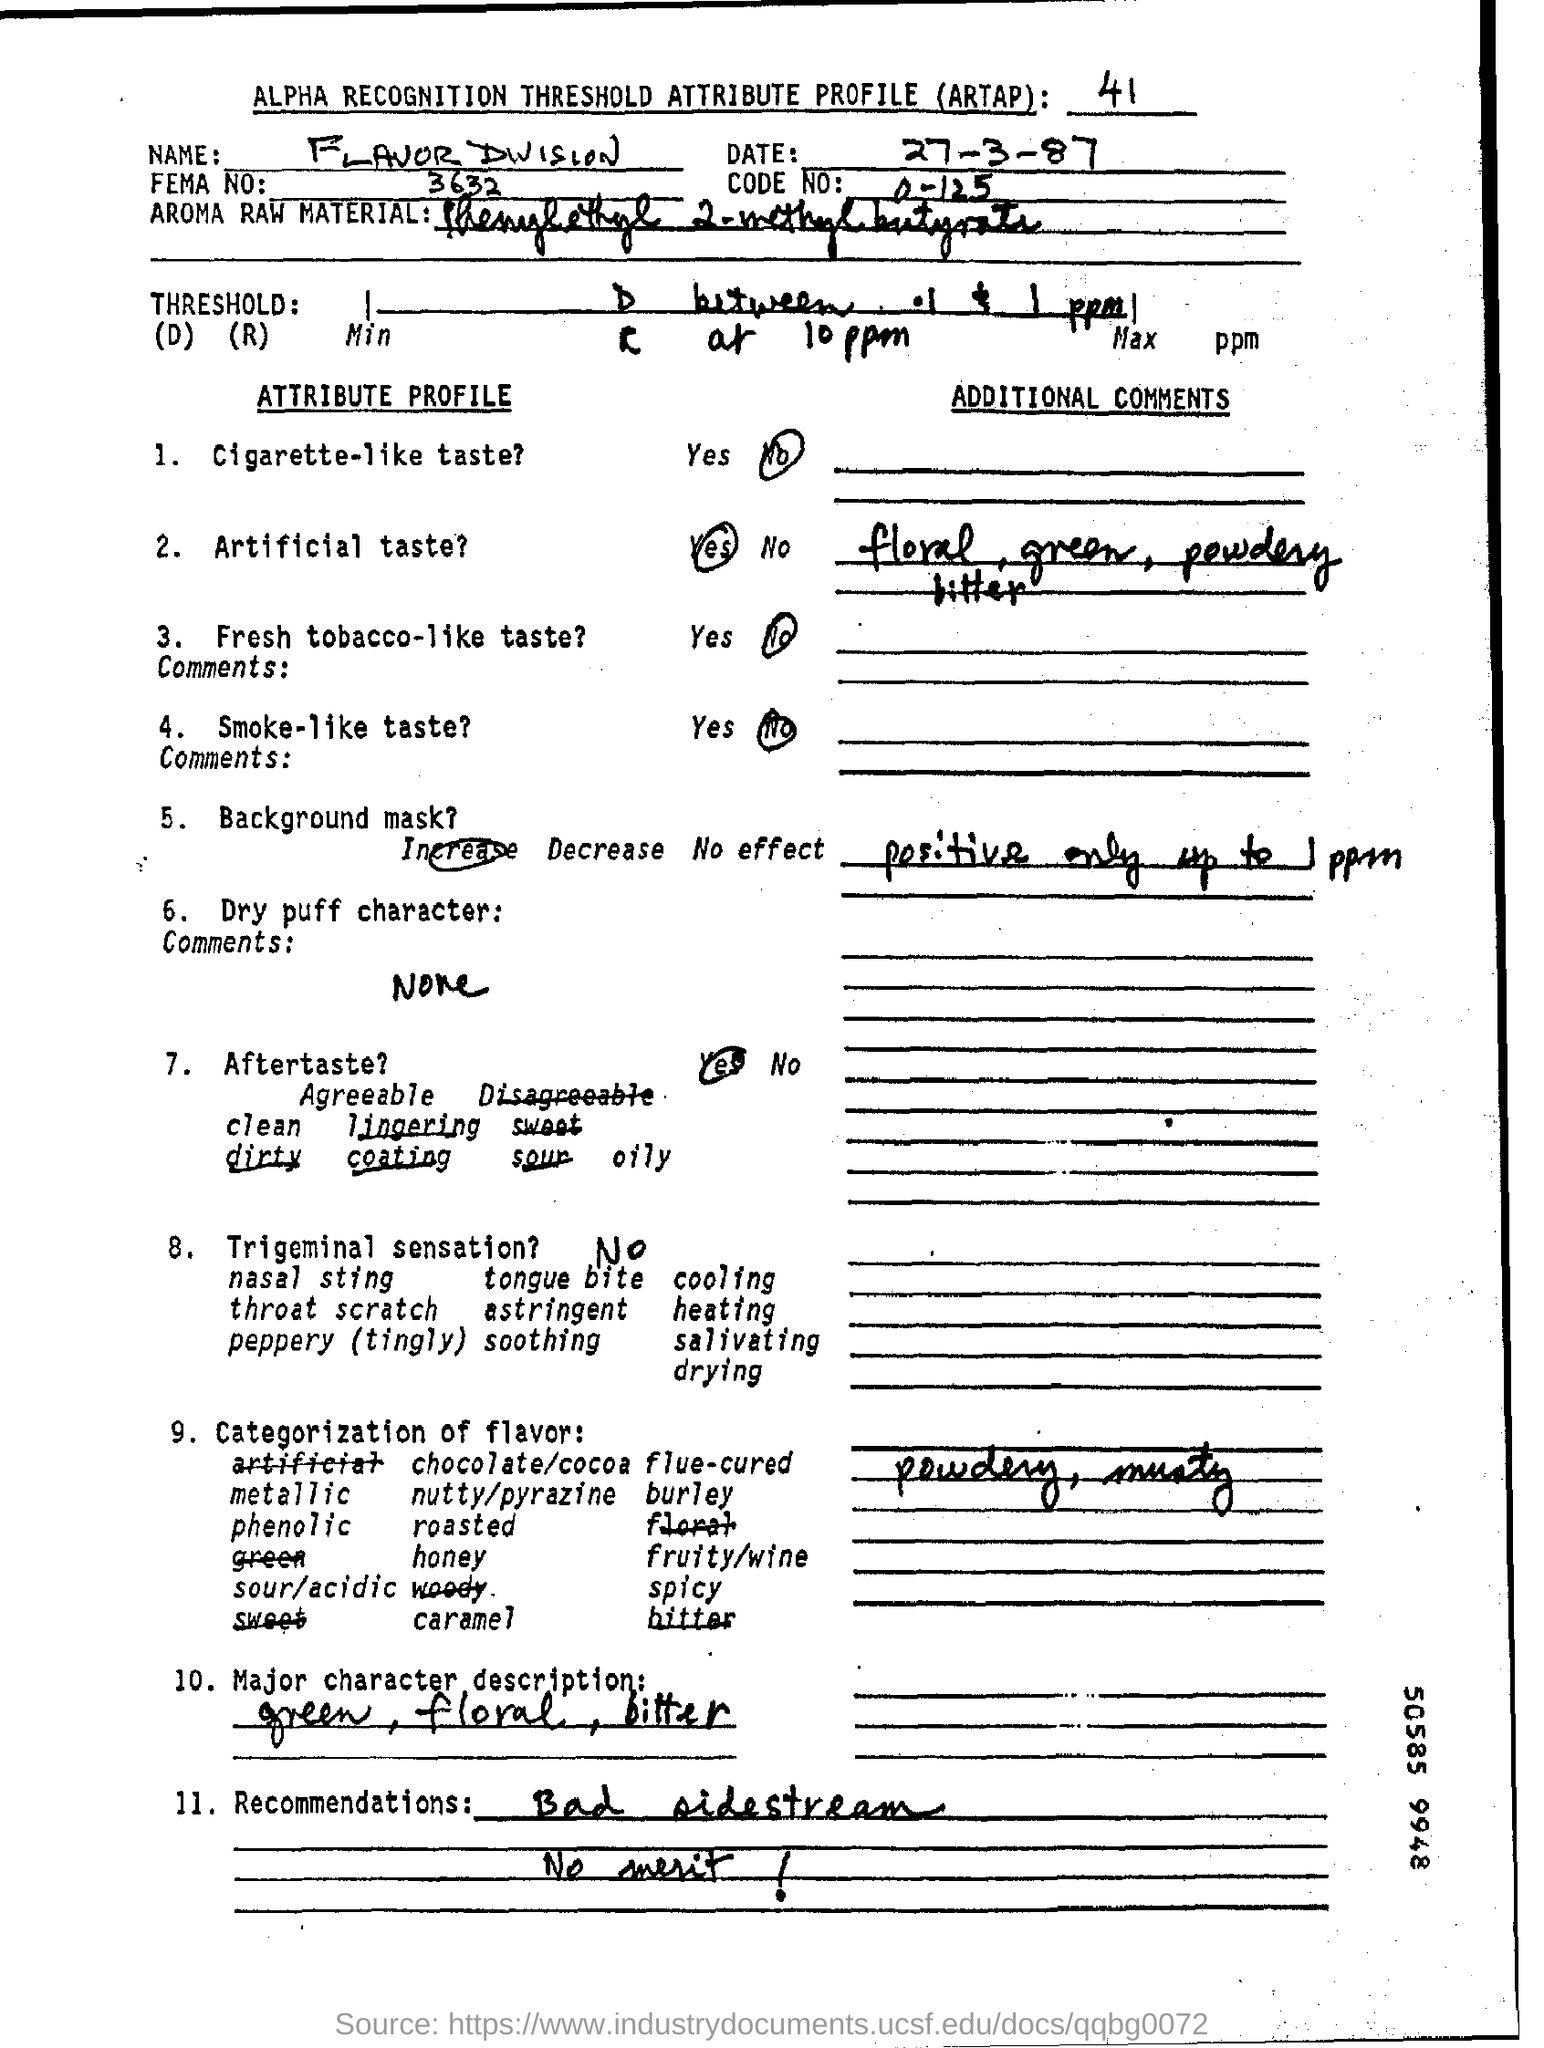What is the date mentioned in the top of the document ?
Make the answer very short. 27-3-87. What is the Code Number ?
Provide a succinct answer. 0-125. What is the FEMA Number ?
Your response must be concise. 3632. 